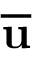<formula> <loc_0><loc_0><loc_500><loc_500>\overline { u }</formula> 